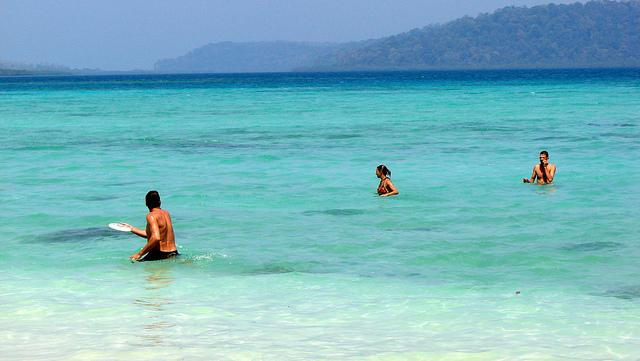What is the man in deep water about to catch?

Choices:
A) frisbee
B) cold
C) whale
D) dolphin ride frisbee 